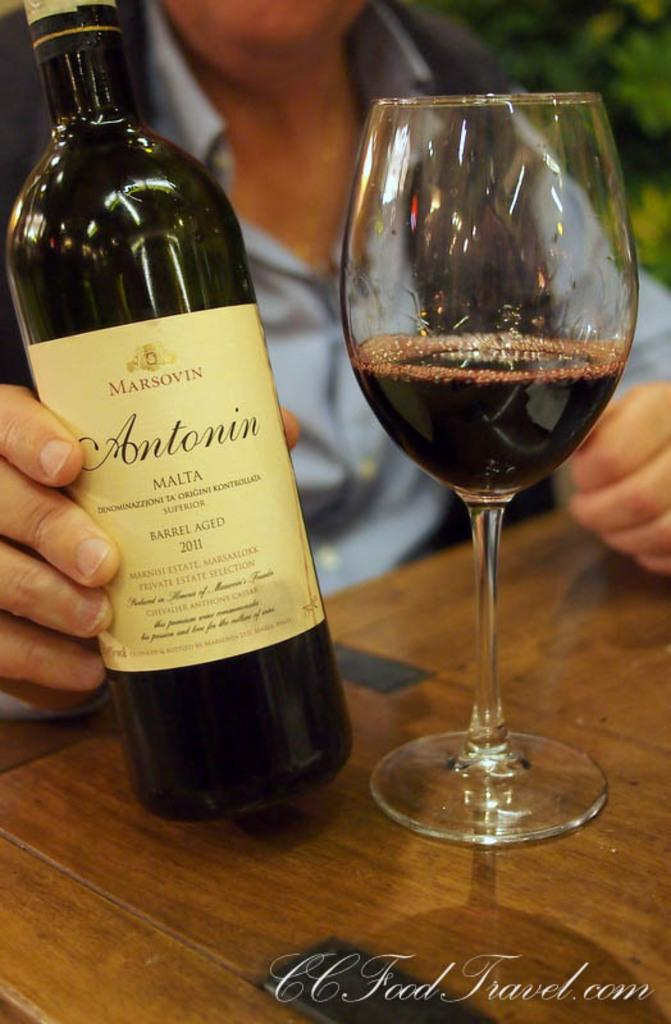Provide a one-sentence caption for the provided image. A bottle of Antonin wine is held next to a wine glass on a table. 